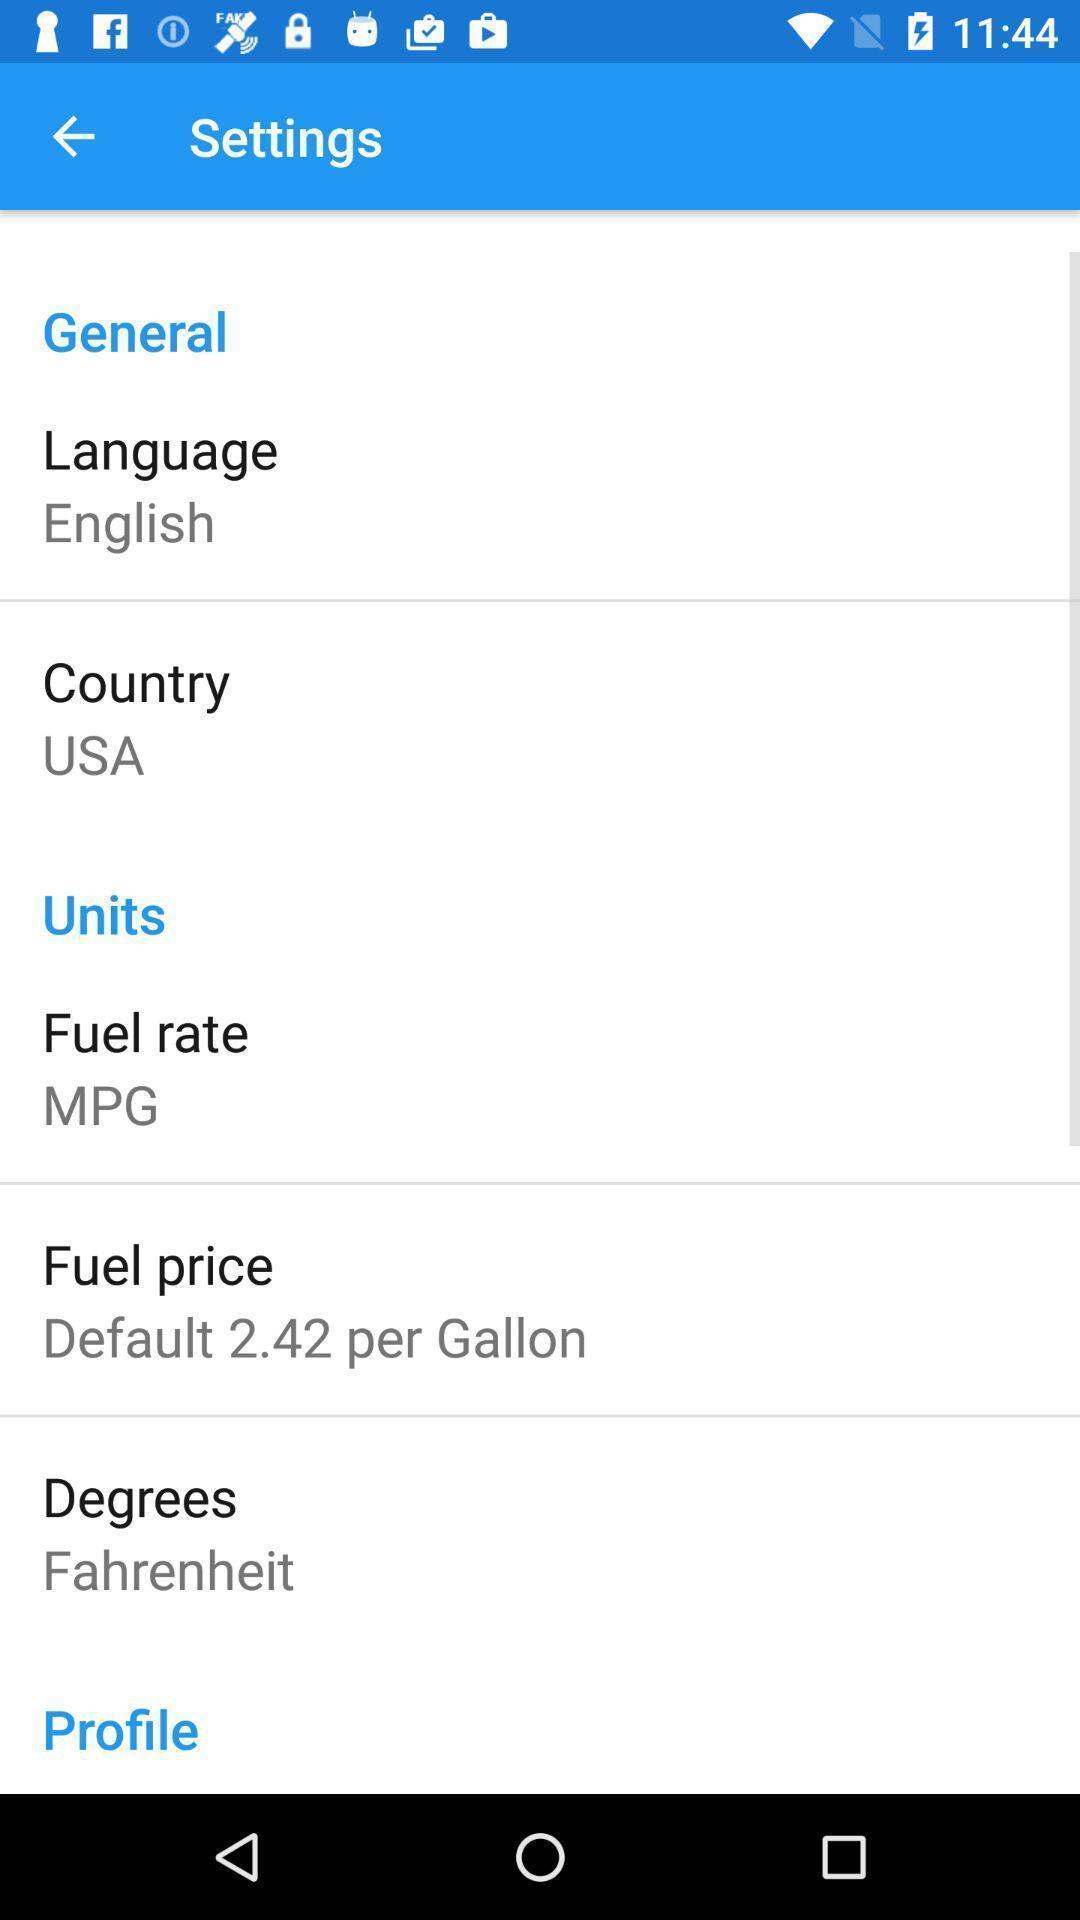Provide a textual representation of this image. Settings page. 